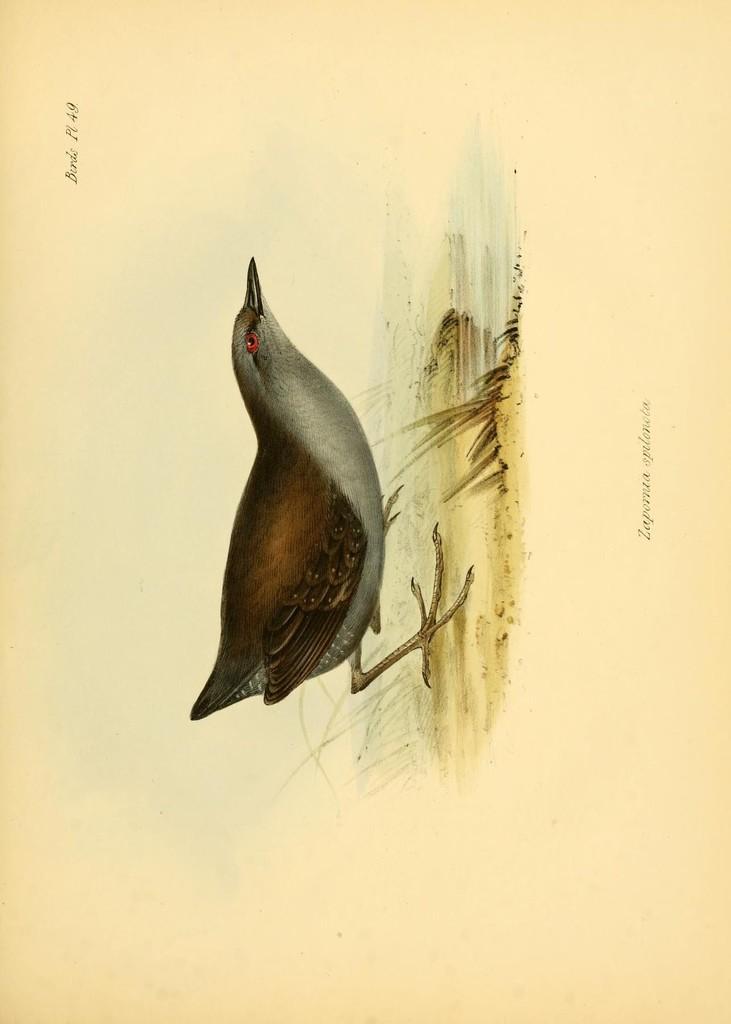Could you give a brief overview of what you see in this image? In the image I can see a painting of a bird and some grass. 